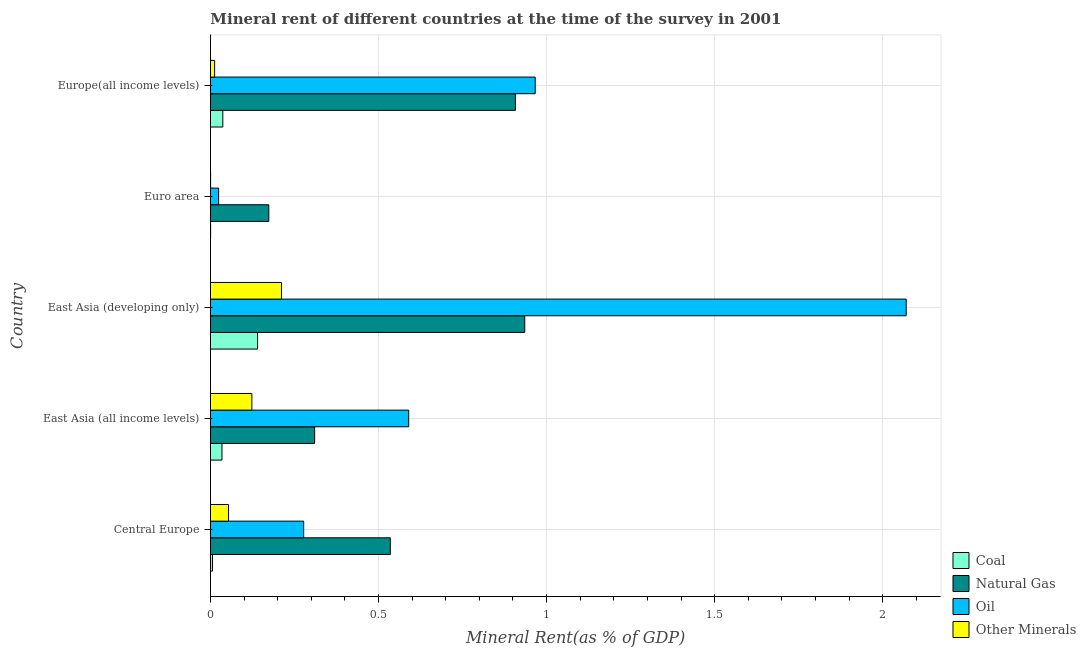How many groups of bars are there?
Give a very brief answer. 5. Are the number of bars on each tick of the Y-axis equal?
Your answer should be compact. Yes. What is the label of the 5th group of bars from the top?
Ensure brevity in your answer.  Central Europe. In how many cases, is the number of bars for a given country not equal to the number of legend labels?
Offer a terse response. 0. What is the coal rent in East Asia (all income levels)?
Your answer should be very brief. 0.03. Across all countries, what is the maximum oil rent?
Make the answer very short. 2.07. Across all countries, what is the minimum oil rent?
Your answer should be compact. 0.02. In which country was the coal rent maximum?
Make the answer very short. East Asia (developing only). In which country was the natural gas rent minimum?
Offer a terse response. Euro area. What is the total  rent of other minerals in the graph?
Your answer should be compact. 0.4. What is the difference between the oil rent in East Asia (all income levels) and that in East Asia (developing only)?
Keep it short and to the point. -1.48. What is the difference between the coal rent in East Asia (all income levels) and the natural gas rent in East Asia (developing only)?
Give a very brief answer. -0.9. What is the average oil rent per country?
Give a very brief answer. 0.79. What is the difference between the coal rent and oil rent in Euro area?
Your answer should be compact. -0.02. What is the ratio of the natural gas rent in East Asia (developing only) to that in Europe(all income levels)?
Give a very brief answer. 1.03. Is the natural gas rent in East Asia (all income levels) less than that in Europe(all income levels)?
Provide a short and direct response. Yes. Is the difference between the oil rent in East Asia (all income levels) and East Asia (developing only) greater than the difference between the coal rent in East Asia (all income levels) and East Asia (developing only)?
Offer a terse response. No. What is the difference between the highest and the second highest coal rent?
Provide a short and direct response. 0.1. What is the difference between the highest and the lowest coal rent?
Ensure brevity in your answer.  0.14. What does the 2nd bar from the top in East Asia (all income levels) represents?
Your answer should be very brief. Oil. What does the 3rd bar from the bottom in Euro area represents?
Keep it short and to the point. Oil. Are all the bars in the graph horizontal?
Offer a very short reply. Yes. Does the graph contain any zero values?
Your answer should be very brief. No. Does the graph contain grids?
Provide a succinct answer. Yes. How are the legend labels stacked?
Provide a succinct answer. Vertical. What is the title of the graph?
Provide a succinct answer. Mineral rent of different countries at the time of the survey in 2001. Does "SF6 gas" appear as one of the legend labels in the graph?
Offer a terse response. No. What is the label or title of the X-axis?
Ensure brevity in your answer.  Mineral Rent(as % of GDP). What is the label or title of the Y-axis?
Provide a short and direct response. Country. What is the Mineral Rent(as % of GDP) in Coal in Central Europe?
Ensure brevity in your answer.  0.01. What is the Mineral Rent(as % of GDP) of Natural Gas in Central Europe?
Give a very brief answer. 0.53. What is the Mineral Rent(as % of GDP) of Oil in Central Europe?
Your response must be concise. 0.28. What is the Mineral Rent(as % of GDP) of Other Minerals in Central Europe?
Your answer should be compact. 0.05. What is the Mineral Rent(as % of GDP) of Coal in East Asia (all income levels)?
Give a very brief answer. 0.03. What is the Mineral Rent(as % of GDP) of Natural Gas in East Asia (all income levels)?
Offer a terse response. 0.31. What is the Mineral Rent(as % of GDP) in Oil in East Asia (all income levels)?
Offer a terse response. 0.59. What is the Mineral Rent(as % of GDP) of Other Minerals in East Asia (all income levels)?
Your response must be concise. 0.12. What is the Mineral Rent(as % of GDP) of Coal in East Asia (developing only)?
Offer a terse response. 0.14. What is the Mineral Rent(as % of GDP) of Natural Gas in East Asia (developing only)?
Give a very brief answer. 0.93. What is the Mineral Rent(as % of GDP) in Oil in East Asia (developing only)?
Provide a short and direct response. 2.07. What is the Mineral Rent(as % of GDP) in Other Minerals in East Asia (developing only)?
Your response must be concise. 0.21. What is the Mineral Rent(as % of GDP) in Coal in Euro area?
Keep it short and to the point. 0. What is the Mineral Rent(as % of GDP) in Natural Gas in Euro area?
Offer a terse response. 0.17. What is the Mineral Rent(as % of GDP) in Oil in Euro area?
Offer a terse response. 0.02. What is the Mineral Rent(as % of GDP) of Other Minerals in Euro area?
Provide a short and direct response. 0. What is the Mineral Rent(as % of GDP) in Coal in Europe(all income levels)?
Your answer should be compact. 0.04. What is the Mineral Rent(as % of GDP) in Natural Gas in Europe(all income levels)?
Give a very brief answer. 0.91. What is the Mineral Rent(as % of GDP) of Oil in Europe(all income levels)?
Your answer should be very brief. 0.97. What is the Mineral Rent(as % of GDP) of Other Minerals in Europe(all income levels)?
Give a very brief answer. 0.01. Across all countries, what is the maximum Mineral Rent(as % of GDP) in Coal?
Offer a very short reply. 0.14. Across all countries, what is the maximum Mineral Rent(as % of GDP) of Natural Gas?
Ensure brevity in your answer.  0.93. Across all countries, what is the maximum Mineral Rent(as % of GDP) in Oil?
Your response must be concise. 2.07. Across all countries, what is the maximum Mineral Rent(as % of GDP) in Other Minerals?
Provide a succinct answer. 0.21. Across all countries, what is the minimum Mineral Rent(as % of GDP) of Coal?
Keep it short and to the point. 0. Across all countries, what is the minimum Mineral Rent(as % of GDP) in Natural Gas?
Provide a succinct answer. 0.17. Across all countries, what is the minimum Mineral Rent(as % of GDP) of Oil?
Your response must be concise. 0.02. Across all countries, what is the minimum Mineral Rent(as % of GDP) in Other Minerals?
Offer a very short reply. 0. What is the total Mineral Rent(as % of GDP) in Coal in the graph?
Offer a terse response. 0.22. What is the total Mineral Rent(as % of GDP) in Natural Gas in the graph?
Offer a terse response. 2.86. What is the total Mineral Rent(as % of GDP) of Oil in the graph?
Offer a terse response. 3.93. What is the total Mineral Rent(as % of GDP) in Other Minerals in the graph?
Ensure brevity in your answer.  0.4. What is the difference between the Mineral Rent(as % of GDP) in Coal in Central Europe and that in East Asia (all income levels)?
Make the answer very short. -0.03. What is the difference between the Mineral Rent(as % of GDP) of Natural Gas in Central Europe and that in East Asia (all income levels)?
Ensure brevity in your answer.  0.23. What is the difference between the Mineral Rent(as % of GDP) in Oil in Central Europe and that in East Asia (all income levels)?
Keep it short and to the point. -0.31. What is the difference between the Mineral Rent(as % of GDP) in Other Minerals in Central Europe and that in East Asia (all income levels)?
Provide a short and direct response. -0.07. What is the difference between the Mineral Rent(as % of GDP) in Coal in Central Europe and that in East Asia (developing only)?
Your answer should be compact. -0.13. What is the difference between the Mineral Rent(as % of GDP) in Oil in Central Europe and that in East Asia (developing only)?
Keep it short and to the point. -1.79. What is the difference between the Mineral Rent(as % of GDP) of Other Minerals in Central Europe and that in East Asia (developing only)?
Give a very brief answer. -0.16. What is the difference between the Mineral Rent(as % of GDP) in Coal in Central Europe and that in Euro area?
Your response must be concise. 0.01. What is the difference between the Mineral Rent(as % of GDP) in Natural Gas in Central Europe and that in Euro area?
Offer a terse response. 0.36. What is the difference between the Mineral Rent(as % of GDP) in Oil in Central Europe and that in Euro area?
Your answer should be very brief. 0.25. What is the difference between the Mineral Rent(as % of GDP) in Other Minerals in Central Europe and that in Euro area?
Offer a terse response. 0.05. What is the difference between the Mineral Rent(as % of GDP) of Coal in Central Europe and that in Europe(all income levels)?
Your response must be concise. -0.03. What is the difference between the Mineral Rent(as % of GDP) of Natural Gas in Central Europe and that in Europe(all income levels)?
Offer a very short reply. -0.37. What is the difference between the Mineral Rent(as % of GDP) of Oil in Central Europe and that in Europe(all income levels)?
Make the answer very short. -0.69. What is the difference between the Mineral Rent(as % of GDP) of Other Minerals in Central Europe and that in Europe(all income levels)?
Your answer should be very brief. 0.04. What is the difference between the Mineral Rent(as % of GDP) in Coal in East Asia (all income levels) and that in East Asia (developing only)?
Your answer should be very brief. -0.11. What is the difference between the Mineral Rent(as % of GDP) in Natural Gas in East Asia (all income levels) and that in East Asia (developing only)?
Provide a short and direct response. -0.63. What is the difference between the Mineral Rent(as % of GDP) in Oil in East Asia (all income levels) and that in East Asia (developing only)?
Offer a very short reply. -1.48. What is the difference between the Mineral Rent(as % of GDP) of Other Minerals in East Asia (all income levels) and that in East Asia (developing only)?
Provide a short and direct response. -0.09. What is the difference between the Mineral Rent(as % of GDP) of Coal in East Asia (all income levels) and that in Euro area?
Provide a short and direct response. 0.03. What is the difference between the Mineral Rent(as % of GDP) in Natural Gas in East Asia (all income levels) and that in Euro area?
Provide a succinct answer. 0.14. What is the difference between the Mineral Rent(as % of GDP) in Oil in East Asia (all income levels) and that in Euro area?
Your answer should be compact. 0.57. What is the difference between the Mineral Rent(as % of GDP) of Other Minerals in East Asia (all income levels) and that in Euro area?
Your response must be concise. 0.12. What is the difference between the Mineral Rent(as % of GDP) of Coal in East Asia (all income levels) and that in Europe(all income levels)?
Your answer should be compact. -0. What is the difference between the Mineral Rent(as % of GDP) of Natural Gas in East Asia (all income levels) and that in Europe(all income levels)?
Your response must be concise. -0.6. What is the difference between the Mineral Rent(as % of GDP) in Oil in East Asia (all income levels) and that in Europe(all income levels)?
Your answer should be very brief. -0.38. What is the difference between the Mineral Rent(as % of GDP) of Other Minerals in East Asia (all income levels) and that in Europe(all income levels)?
Provide a short and direct response. 0.11. What is the difference between the Mineral Rent(as % of GDP) in Coal in East Asia (developing only) and that in Euro area?
Make the answer very short. 0.14. What is the difference between the Mineral Rent(as % of GDP) of Natural Gas in East Asia (developing only) and that in Euro area?
Keep it short and to the point. 0.76. What is the difference between the Mineral Rent(as % of GDP) in Oil in East Asia (developing only) and that in Euro area?
Give a very brief answer. 2.05. What is the difference between the Mineral Rent(as % of GDP) of Other Minerals in East Asia (developing only) and that in Euro area?
Ensure brevity in your answer.  0.21. What is the difference between the Mineral Rent(as % of GDP) in Coal in East Asia (developing only) and that in Europe(all income levels)?
Your answer should be compact. 0.1. What is the difference between the Mineral Rent(as % of GDP) in Natural Gas in East Asia (developing only) and that in Europe(all income levels)?
Offer a very short reply. 0.03. What is the difference between the Mineral Rent(as % of GDP) of Oil in East Asia (developing only) and that in Europe(all income levels)?
Give a very brief answer. 1.1. What is the difference between the Mineral Rent(as % of GDP) in Other Minerals in East Asia (developing only) and that in Europe(all income levels)?
Offer a terse response. 0.2. What is the difference between the Mineral Rent(as % of GDP) in Coal in Euro area and that in Europe(all income levels)?
Your answer should be very brief. -0.04. What is the difference between the Mineral Rent(as % of GDP) of Natural Gas in Euro area and that in Europe(all income levels)?
Offer a very short reply. -0.73. What is the difference between the Mineral Rent(as % of GDP) of Oil in Euro area and that in Europe(all income levels)?
Offer a very short reply. -0.94. What is the difference between the Mineral Rent(as % of GDP) of Other Minerals in Euro area and that in Europe(all income levels)?
Provide a succinct answer. -0.01. What is the difference between the Mineral Rent(as % of GDP) of Coal in Central Europe and the Mineral Rent(as % of GDP) of Natural Gas in East Asia (all income levels)?
Provide a short and direct response. -0.3. What is the difference between the Mineral Rent(as % of GDP) in Coal in Central Europe and the Mineral Rent(as % of GDP) in Oil in East Asia (all income levels)?
Ensure brevity in your answer.  -0.58. What is the difference between the Mineral Rent(as % of GDP) of Coal in Central Europe and the Mineral Rent(as % of GDP) of Other Minerals in East Asia (all income levels)?
Ensure brevity in your answer.  -0.12. What is the difference between the Mineral Rent(as % of GDP) of Natural Gas in Central Europe and the Mineral Rent(as % of GDP) of Oil in East Asia (all income levels)?
Your answer should be very brief. -0.05. What is the difference between the Mineral Rent(as % of GDP) in Natural Gas in Central Europe and the Mineral Rent(as % of GDP) in Other Minerals in East Asia (all income levels)?
Your answer should be very brief. 0.41. What is the difference between the Mineral Rent(as % of GDP) of Oil in Central Europe and the Mineral Rent(as % of GDP) of Other Minerals in East Asia (all income levels)?
Provide a short and direct response. 0.15. What is the difference between the Mineral Rent(as % of GDP) of Coal in Central Europe and the Mineral Rent(as % of GDP) of Natural Gas in East Asia (developing only)?
Ensure brevity in your answer.  -0.93. What is the difference between the Mineral Rent(as % of GDP) of Coal in Central Europe and the Mineral Rent(as % of GDP) of Oil in East Asia (developing only)?
Provide a short and direct response. -2.06. What is the difference between the Mineral Rent(as % of GDP) of Coal in Central Europe and the Mineral Rent(as % of GDP) of Other Minerals in East Asia (developing only)?
Your answer should be very brief. -0.21. What is the difference between the Mineral Rent(as % of GDP) of Natural Gas in Central Europe and the Mineral Rent(as % of GDP) of Oil in East Asia (developing only)?
Offer a terse response. -1.53. What is the difference between the Mineral Rent(as % of GDP) in Natural Gas in Central Europe and the Mineral Rent(as % of GDP) in Other Minerals in East Asia (developing only)?
Provide a short and direct response. 0.32. What is the difference between the Mineral Rent(as % of GDP) in Oil in Central Europe and the Mineral Rent(as % of GDP) in Other Minerals in East Asia (developing only)?
Your answer should be compact. 0.07. What is the difference between the Mineral Rent(as % of GDP) of Coal in Central Europe and the Mineral Rent(as % of GDP) of Natural Gas in Euro area?
Keep it short and to the point. -0.17. What is the difference between the Mineral Rent(as % of GDP) of Coal in Central Europe and the Mineral Rent(as % of GDP) of Oil in Euro area?
Your answer should be compact. -0.02. What is the difference between the Mineral Rent(as % of GDP) of Coal in Central Europe and the Mineral Rent(as % of GDP) of Other Minerals in Euro area?
Make the answer very short. 0.01. What is the difference between the Mineral Rent(as % of GDP) in Natural Gas in Central Europe and the Mineral Rent(as % of GDP) in Oil in Euro area?
Give a very brief answer. 0.51. What is the difference between the Mineral Rent(as % of GDP) of Natural Gas in Central Europe and the Mineral Rent(as % of GDP) of Other Minerals in Euro area?
Offer a very short reply. 0.53. What is the difference between the Mineral Rent(as % of GDP) of Oil in Central Europe and the Mineral Rent(as % of GDP) of Other Minerals in Euro area?
Offer a very short reply. 0.28. What is the difference between the Mineral Rent(as % of GDP) in Coal in Central Europe and the Mineral Rent(as % of GDP) in Natural Gas in Europe(all income levels)?
Ensure brevity in your answer.  -0.9. What is the difference between the Mineral Rent(as % of GDP) of Coal in Central Europe and the Mineral Rent(as % of GDP) of Oil in Europe(all income levels)?
Give a very brief answer. -0.96. What is the difference between the Mineral Rent(as % of GDP) of Coal in Central Europe and the Mineral Rent(as % of GDP) of Other Minerals in Europe(all income levels)?
Your answer should be very brief. -0.01. What is the difference between the Mineral Rent(as % of GDP) of Natural Gas in Central Europe and the Mineral Rent(as % of GDP) of Oil in Europe(all income levels)?
Your answer should be very brief. -0.43. What is the difference between the Mineral Rent(as % of GDP) of Natural Gas in Central Europe and the Mineral Rent(as % of GDP) of Other Minerals in Europe(all income levels)?
Your response must be concise. 0.52. What is the difference between the Mineral Rent(as % of GDP) in Oil in Central Europe and the Mineral Rent(as % of GDP) in Other Minerals in Europe(all income levels)?
Keep it short and to the point. 0.27. What is the difference between the Mineral Rent(as % of GDP) of Coal in East Asia (all income levels) and the Mineral Rent(as % of GDP) of Natural Gas in East Asia (developing only)?
Provide a short and direct response. -0.9. What is the difference between the Mineral Rent(as % of GDP) in Coal in East Asia (all income levels) and the Mineral Rent(as % of GDP) in Oil in East Asia (developing only)?
Keep it short and to the point. -2.04. What is the difference between the Mineral Rent(as % of GDP) of Coal in East Asia (all income levels) and the Mineral Rent(as % of GDP) of Other Minerals in East Asia (developing only)?
Keep it short and to the point. -0.18. What is the difference between the Mineral Rent(as % of GDP) of Natural Gas in East Asia (all income levels) and the Mineral Rent(as % of GDP) of Oil in East Asia (developing only)?
Offer a terse response. -1.76. What is the difference between the Mineral Rent(as % of GDP) of Natural Gas in East Asia (all income levels) and the Mineral Rent(as % of GDP) of Other Minerals in East Asia (developing only)?
Your answer should be very brief. 0.1. What is the difference between the Mineral Rent(as % of GDP) in Oil in East Asia (all income levels) and the Mineral Rent(as % of GDP) in Other Minerals in East Asia (developing only)?
Ensure brevity in your answer.  0.38. What is the difference between the Mineral Rent(as % of GDP) of Coal in East Asia (all income levels) and the Mineral Rent(as % of GDP) of Natural Gas in Euro area?
Keep it short and to the point. -0.14. What is the difference between the Mineral Rent(as % of GDP) of Coal in East Asia (all income levels) and the Mineral Rent(as % of GDP) of Other Minerals in Euro area?
Offer a terse response. 0.03. What is the difference between the Mineral Rent(as % of GDP) in Natural Gas in East Asia (all income levels) and the Mineral Rent(as % of GDP) in Oil in Euro area?
Provide a short and direct response. 0.29. What is the difference between the Mineral Rent(as % of GDP) in Natural Gas in East Asia (all income levels) and the Mineral Rent(as % of GDP) in Other Minerals in Euro area?
Offer a terse response. 0.31. What is the difference between the Mineral Rent(as % of GDP) of Oil in East Asia (all income levels) and the Mineral Rent(as % of GDP) of Other Minerals in Euro area?
Provide a short and direct response. 0.59. What is the difference between the Mineral Rent(as % of GDP) in Coal in East Asia (all income levels) and the Mineral Rent(as % of GDP) in Natural Gas in Europe(all income levels)?
Your answer should be compact. -0.87. What is the difference between the Mineral Rent(as % of GDP) of Coal in East Asia (all income levels) and the Mineral Rent(as % of GDP) of Oil in Europe(all income levels)?
Your response must be concise. -0.93. What is the difference between the Mineral Rent(as % of GDP) in Coal in East Asia (all income levels) and the Mineral Rent(as % of GDP) in Other Minerals in Europe(all income levels)?
Give a very brief answer. 0.02. What is the difference between the Mineral Rent(as % of GDP) of Natural Gas in East Asia (all income levels) and the Mineral Rent(as % of GDP) of Oil in Europe(all income levels)?
Your answer should be very brief. -0.66. What is the difference between the Mineral Rent(as % of GDP) of Natural Gas in East Asia (all income levels) and the Mineral Rent(as % of GDP) of Other Minerals in Europe(all income levels)?
Give a very brief answer. 0.3. What is the difference between the Mineral Rent(as % of GDP) in Oil in East Asia (all income levels) and the Mineral Rent(as % of GDP) in Other Minerals in Europe(all income levels)?
Your response must be concise. 0.58. What is the difference between the Mineral Rent(as % of GDP) of Coal in East Asia (developing only) and the Mineral Rent(as % of GDP) of Natural Gas in Euro area?
Offer a very short reply. -0.03. What is the difference between the Mineral Rent(as % of GDP) of Coal in East Asia (developing only) and the Mineral Rent(as % of GDP) of Oil in Euro area?
Your answer should be compact. 0.12. What is the difference between the Mineral Rent(as % of GDP) in Coal in East Asia (developing only) and the Mineral Rent(as % of GDP) in Other Minerals in Euro area?
Offer a very short reply. 0.14. What is the difference between the Mineral Rent(as % of GDP) in Natural Gas in East Asia (developing only) and the Mineral Rent(as % of GDP) in Oil in Euro area?
Your answer should be compact. 0.91. What is the difference between the Mineral Rent(as % of GDP) of Natural Gas in East Asia (developing only) and the Mineral Rent(as % of GDP) of Other Minerals in Euro area?
Provide a succinct answer. 0.93. What is the difference between the Mineral Rent(as % of GDP) in Oil in East Asia (developing only) and the Mineral Rent(as % of GDP) in Other Minerals in Euro area?
Offer a terse response. 2.07. What is the difference between the Mineral Rent(as % of GDP) of Coal in East Asia (developing only) and the Mineral Rent(as % of GDP) of Natural Gas in Europe(all income levels)?
Give a very brief answer. -0.77. What is the difference between the Mineral Rent(as % of GDP) of Coal in East Asia (developing only) and the Mineral Rent(as % of GDP) of Oil in Europe(all income levels)?
Provide a short and direct response. -0.83. What is the difference between the Mineral Rent(as % of GDP) of Coal in East Asia (developing only) and the Mineral Rent(as % of GDP) of Other Minerals in Europe(all income levels)?
Provide a short and direct response. 0.13. What is the difference between the Mineral Rent(as % of GDP) of Natural Gas in East Asia (developing only) and the Mineral Rent(as % of GDP) of Oil in Europe(all income levels)?
Offer a very short reply. -0.03. What is the difference between the Mineral Rent(as % of GDP) in Natural Gas in East Asia (developing only) and the Mineral Rent(as % of GDP) in Other Minerals in Europe(all income levels)?
Offer a very short reply. 0.92. What is the difference between the Mineral Rent(as % of GDP) of Oil in East Asia (developing only) and the Mineral Rent(as % of GDP) of Other Minerals in Europe(all income levels)?
Your answer should be compact. 2.06. What is the difference between the Mineral Rent(as % of GDP) in Coal in Euro area and the Mineral Rent(as % of GDP) in Natural Gas in Europe(all income levels)?
Give a very brief answer. -0.91. What is the difference between the Mineral Rent(as % of GDP) of Coal in Euro area and the Mineral Rent(as % of GDP) of Oil in Europe(all income levels)?
Ensure brevity in your answer.  -0.97. What is the difference between the Mineral Rent(as % of GDP) of Coal in Euro area and the Mineral Rent(as % of GDP) of Other Minerals in Europe(all income levels)?
Your answer should be compact. -0.01. What is the difference between the Mineral Rent(as % of GDP) in Natural Gas in Euro area and the Mineral Rent(as % of GDP) in Oil in Europe(all income levels)?
Offer a very short reply. -0.79. What is the difference between the Mineral Rent(as % of GDP) in Natural Gas in Euro area and the Mineral Rent(as % of GDP) in Other Minerals in Europe(all income levels)?
Your answer should be compact. 0.16. What is the difference between the Mineral Rent(as % of GDP) of Oil in Euro area and the Mineral Rent(as % of GDP) of Other Minerals in Europe(all income levels)?
Provide a succinct answer. 0.01. What is the average Mineral Rent(as % of GDP) in Coal per country?
Make the answer very short. 0.04. What is the average Mineral Rent(as % of GDP) of Natural Gas per country?
Offer a very short reply. 0.57. What is the average Mineral Rent(as % of GDP) in Oil per country?
Offer a terse response. 0.79. What is the average Mineral Rent(as % of GDP) in Other Minerals per country?
Your response must be concise. 0.08. What is the difference between the Mineral Rent(as % of GDP) in Coal and Mineral Rent(as % of GDP) in Natural Gas in Central Europe?
Give a very brief answer. -0.53. What is the difference between the Mineral Rent(as % of GDP) of Coal and Mineral Rent(as % of GDP) of Oil in Central Europe?
Your answer should be very brief. -0.27. What is the difference between the Mineral Rent(as % of GDP) in Coal and Mineral Rent(as % of GDP) in Other Minerals in Central Europe?
Your answer should be compact. -0.05. What is the difference between the Mineral Rent(as % of GDP) in Natural Gas and Mineral Rent(as % of GDP) in Oil in Central Europe?
Your response must be concise. 0.26. What is the difference between the Mineral Rent(as % of GDP) of Natural Gas and Mineral Rent(as % of GDP) of Other Minerals in Central Europe?
Provide a succinct answer. 0.48. What is the difference between the Mineral Rent(as % of GDP) in Oil and Mineral Rent(as % of GDP) in Other Minerals in Central Europe?
Provide a succinct answer. 0.22. What is the difference between the Mineral Rent(as % of GDP) in Coal and Mineral Rent(as % of GDP) in Natural Gas in East Asia (all income levels)?
Make the answer very short. -0.28. What is the difference between the Mineral Rent(as % of GDP) of Coal and Mineral Rent(as % of GDP) of Oil in East Asia (all income levels)?
Keep it short and to the point. -0.56. What is the difference between the Mineral Rent(as % of GDP) in Coal and Mineral Rent(as % of GDP) in Other Minerals in East Asia (all income levels)?
Your answer should be compact. -0.09. What is the difference between the Mineral Rent(as % of GDP) of Natural Gas and Mineral Rent(as % of GDP) of Oil in East Asia (all income levels)?
Make the answer very short. -0.28. What is the difference between the Mineral Rent(as % of GDP) in Natural Gas and Mineral Rent(as % of GDP) in Other Minerals in East Asia (all income levels)?
Make the answer very short. 0.19. What is the difference between the Mineral Rent(as % of GDP) of Oil and Mineral Rent(as % of GDP) of Other Minerals in East Asia (all income levels)?
Keep it short and to the point. 0.47. What is the difference between the Mineral Rent(as % of GDP) in Coal and Mineral Rent(as % of GDP) in Natural Gas in East Asia (developing only)?
Your response must be concise. -0.79. What is the difference between the Mineral Rent(as % of GDP) in Coal and Mineral Rent(as % of GDP) in Oil in East Asia (developing only)?
Provide a short and direct response. -1.93. What is the difference between the Mineral Rent(as % of GDP) in Coal and Mineral Rent(as % of GDP) in Other Minerals in East Asia (developing only)?
Offer a terse response. -0.07. What is the difference between the Mineral Rent(as % of GDP) in Natural Gas and Mineral Rent(as % of GDP) in Oil in East Asia (developing only)?
Provide a short and direct response. -1.13. What is the difference between the Mineral Rent(as % of GDP) of Natural Gas and Mineral Rent(as % of GDP) of Other Minerals in East Asia (developing only)?
Provide a short and direct response. 0.72. What is the difference between the Mineral Rent(as % of GDP) of Oil and Mineral Rent(as % of GDP) of Other Minerals in East Asia (developing only)?
Your answer should be very brief. 1.86. What is the difference between the Mineral Rent(as % of GDP) in Coal and Mineral Rent(as % of GDP) in Natural Gas in Euro area?
Your answer should be very brief. -0.17. What is the difference between the Mineral Rent(as % of GDP) of Coal and Mineral Rent(as % of GDP) of Oil in Euro area?
Offer a very short reply. -0.02. What is the difference between the Mineral Rent(as % of GDP) in Coal and Mineral Rent(as % of GDP) in Other Minerals in Euro area?
Keep it short and to the point. 0. What is the difference between the Mineral Rent(as % of GDP) of Natural Gas and Mineral Rent(as % of GDP) of Oil in Euro area?
Your answer should be compact. 0.15. What is the difference between the Mineral Rent(as % of GDP) in Natural Gas and Mineral Rent(as % of GDP) in Other Minerals in Euro area?
Keep it short and to the point. 0.17. What is the difference between the Mineral Rent(as % of GDP) of Oil and Mineral Rent(as % of GDP) of Other Minerals in Euro area?
Your answer should be very brief. 0.02. What is the difference between the Mineral Rent(as % of GDP) of Coal and Mineral Rent(as % of GDP) of Natural Gas in Europe(all income levels)?
Offer a very short reply. -0.87. What is the difference between the Mineral Rent(as % of GDP) in Coal and Mineral Rent(as % of GDP) in Oil in Europe(all income levels)?
Offer a terse response. -0.93. What is the difference between the Mineral Rent(as % of GDP) in Coal and Mineral Rent(as % of GDP) in Other Minerals in Europe(all income levels)?
Make the answer very short. 0.02. What is the difference between the Mineral Rent(as % of GDP) of Natural Gas and Mineral Rent(as % of GDP) of Oil in Europe(all income levels)?
Your response must be concise. -0.06. What is the difference between the Mineral Rent(as % of GDP) in Natural Gas and Mineral Rent(as % of GDP) in Other Minerals in Europe(all income levels)?
Provide a short and direct response. 0.89. What is the difference between the Mineral Rent(as % of GDP) in Oil and Mineral Rent(as % of GDP) in Other Minerals in Europe(all income levels)?
Your response must be concise. 0.95. What is the ratio of the Mineral Rent(as % of GDP) in Coal in Central Europe to that in East Asia (all income levels)?
Offer a very short reply. 0.18. What is the ratio of the Mineral Rent(as % of GDP) in Natural Gas in Central Europe to that in East Asia (all income levels)?
Your answer should be very brief. 1.73. What is the ratio of the Mineral Rent(as % of GDP) in Oil in Central Europe to that in East Asia (all income levels)?
Keep it short and to the point. 0.47. What is the ratio of the Mineral Rent(as % of GDP) of Other Minerals in Central Europe to that in East Asia (all income levels)?
Offer a terse response. 0.44. What is the ratio of the Mineral Rent(as % of GDP) in Coal in Central Europe to that in East Asia (developing only)?
Offer a terse response. 0.04. What is the ratio of the Mineral Rent(as % of GDP) of Natural Gas in Central Europe to that in East Asia (developing only)?
Give a very brief answer. 0.57. What is the ratio of the Mineral Rent(as % of GDP) in Oil in Central Europe to that in East Asia (developing only)?
Provide a short and direct response. 0.13. What is the ratio of the Mineral Rent(as % of GDP) in Other Minerals in Central Europe to that in East Asia (developing only)?
Offer a very short reply. 0.25. What is the ratio of the Mineral Rent(as % of GDP) of Coal in Central Europe to that in Euro area?
Ensure brevity in your answer.  14.44. What is the ratio of the Mineral Rent(as % of GDP) in Natural Gas in Central Europe to that in Euro area?
Ensure brevity in your answer.  3.08. What is the ratio of the Mineral Rent(as % of GDP) of Oil in Central Europe to that in Euro area?
Your answer should be compact. 11.47. What is the ratio of the Mineral Rent(as % of GDP) in Other Minerals in Central Europe to that in Euro area?
Provide a succinct answer. 144.68. What is the ratio of the Mineral Rent(as % of GDP) in Coal in Central Europe to that in Europe(all income levels)?
Provide a succinct answer. 0.17. What is the ratio of the Mineral Rent(as % of GDP) of Natural Gas in Central Europe to that in Europe(all income levels)?
Provide a short and direct response. 0.59. What is the ratio of the Mineral Rent(as % of GDP) in Oil in Central Europe to that in Europe(all income levels)?
Make the answer very short. 0.29. What is the ratio of the Mineral Rent(as % of GDP) in Other Minerals in Central Europe to that in Europe(all income levels)?
Give a very brief answer. 4.36. What is the ratio of the Mineral Rent(as % of GDP) in Coal in East Asia (all income levels) to that in East Asia (developing only)?
Your answer should be very brief. 0.24. What is the ratio of the Mineral Rent(as % of GDP) of Natural Gas in East Asia (all income levels) to that in East Asia (developing only)?
Provide a short and direct response. 0.33. What is the ratio of the Mineral Rent(as % of GDP) in Oil in East Asia (all income levels) to that in East Asia (developing only)?
Provide a succinct answer. 0.28. What is the ratio of the Mineral Rent(as % of GDP) in Other Minerals in East Asia (all income levels) to that in East Asia (developing only)?
Your answer should be compact. 0.58. What is the ratio of the Mineral Rent(as % of GDP) in Coal in East Asia (all income levels) to that in Euro area?
Offer a terse response. 81.49. What is the ratio of the Mineral Rent(as % of GDP) of Natural Gas in East Asia (all income levels) to that in Euro area?
Provide a short and direct response. 1.78. What is the ratio of the Mineral Rent(as % of GDP) of Oil in East Asia (all income levels) to that in Euro area?
Make the answer very short. 24.38. What is the ratio of the Mineral Rent(as % of GDP) in Other Minerals in East Asia (all income levels) to that in Euro area?
Offer a very short reply. 331.06. What is the ratio of the Mineral Rent(as % of GDP) of Coal in East Asia (all income levels) to that in Europe(all income levels)?
Provide a succinct answer. 0.93. What is the ratio of the Mineral Rent(as % of GDP) of Natural Gas in East Asia (all income levels) to that in Europe(all income levels)?
Keep it short and to the point. 0.34. What is the ratio of the Mineral Rent(as % of GDP) in Oil in East Asia (all income levels) to that in Europe(all income levels)?
Keep it short and to the point. 0.61. What is the ratio of the Mineral Rent(as % of GDP) of Other Minerals in East Asia (all income levels) to that in Europe(all income levels)?
Your answer should be compact. 9.98. What is the ratio of the Mineral Rent(as % of GDP) in Coal in East Asia (developing only) to that in Euro area?
Your response must be concise. 333.72. What is the ratio of the Mineral Rent(as % of GDP) in Natural Gas in East Asia (developing only) to that in Euro area?
Give a very brief answer. 5.39. What is the ratio of the Mineral Rent(as % of GDP) of Oil in East Asia (developing only) to that in Euro area?
Give a very brief answer. 85.58. What is the ratio of the Mineral Rent(as % of GDP) of Other Minerals in East Asia (developing only) to that in Euro area?
Make the answer very short. 567.97. What is the ratio of the Mineral Rent(as % of GDP) in Coal in East Asia (developing only) to that in Europe(all income levels)?
Your answer should be compact. 3.82. What is the ratio of the Mineral Rent(as % of GDP) of Natural Gas in East Asia (developing only) to that in Europe(all income levels)?
Keep it short and to the point. 1.03. What is the ratio of the Mineral Rent(as % of GDP) of Oil in East Asia (developing only) to that in Europe(all income levels)?
Keep it short and to the point. 2.14. What is the ratio of the Mineral Rent(as % of GDP) in Other Minerals in East Asia (developing only) to that in Europe(all income levels)?
Ensure brevity in your answer.  17.12. What is the ratio of the Mineral Rent(as % of GDP) of Coal in Euro area to that in Europe(all income levels)?
Provide a succinct answer. 0.01. What is the ratio of the Mineral Rent(as % of GDP) of Natural Gas in Euro area to that in Europe(all income levels)?
Offer a terse response. 0.19. What is the ratio of the Mineral Rent(as % of GDP) in Oil in Euro area to that in Europe(all income levels)?
Your answer should be compact. 0.03. What is the ratio of the Mineral Rent(as % of GDP) in Other Minerals in Euro area to that in Europe(all income levels)?
Your answer should be very brief. 0.03. What is the difference between the highest and the second highest Mineral Rent(as % of GDP) in Coal?
Your answer should be very brief. 0.1. What is the difference between the highest and the second highest Mineral Rent(as % of GDP) of Natural Gas?
Keep it short and to the point. 0.03. What is the difference between the highest and the second highest Mineral Rent(as % of GDP) in Oil?
Your answer should be very brief. 1.1. What is the difference between the highest and the second highest Mineral Rent(as % of GDP) in Other Minerals?
Provide a succinct answer. 0.09. What is the difference between the highest and the lowest Mineral Rent(as % of GDP) of Coal?
Keep it short and to the point. 0.14. What is the difference between the highest and the lowest Mineral Rent(as % of GDP) of Natural Gas?
Give a very brief answer. 0.76. What is the difference between the highest and the lowest Mineral Rent(as % of GDP) in Oil?
Give a very brief answer. 2.05. What is the difference between the highest and the lowest Mineral Rent(as % of GDP) of Other Minerals?
Offer a terse response. 0.21. 